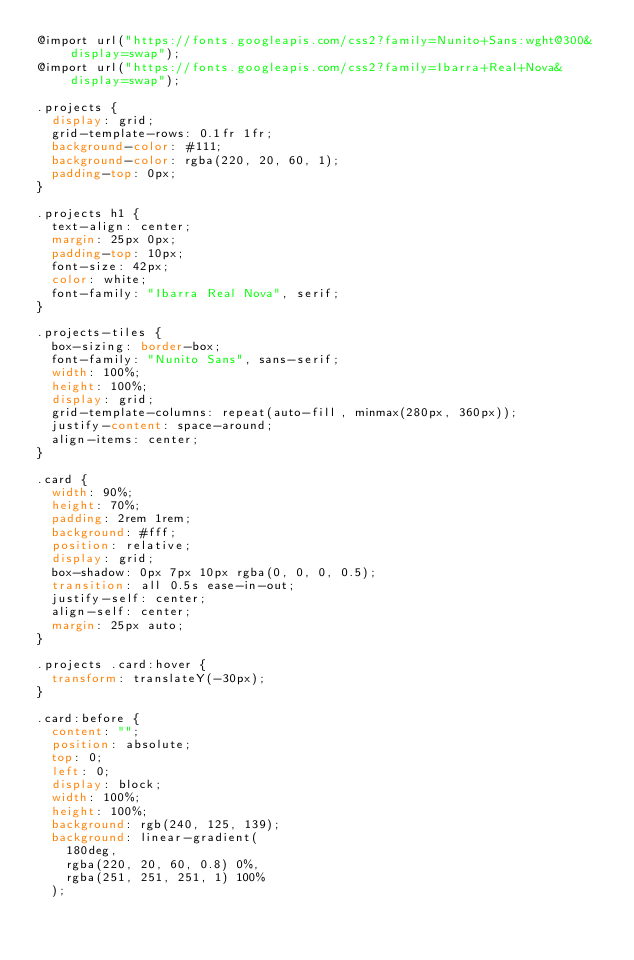<code> <loc_0><loc_0><loc_500><loc_500><_CSS_>@import url("https://fonts.googleapis.com/css2?family=Nunito+Sans:wght@300&display=swap");
@import url("https://fonts.googleapis.com/css2?family=Ibarra+Real+Nova&display=swap");

.projects {
  display: grid;
  grid-template-rows: 0.1fr 1fr;
  background-color: #111;
  background-color: rgba(220, 20, 60, 1);
  padding-top: 0px;
}

.projects h1 {
  text-align: center;
  margin: 25px 0px;
  padding-top: 10px;
  font-size: 42px;
  color: white;
  font-family: "Ibarra Real Nova", serif;
}

.projects-tiles {
  box-sizing: border-box;
  font-family: "Nunito Sans", sans-serif;
  width: 100%;
  height: 100%;
  display: grid;
  grid-template-columns: repeat(auto-fill, minmax(280px, 360px));
  justify-content: space-around;
  align-items: center;
}

.card {
  width: 90%;
  height: 70%;
  padding: 2rem 1rem;
  background: #fff;
  position: relative;
  display: grid;
  box-shadow: 0px 7px 10px rgba(0, 0, 0, 0.5);
  transition: all 0.5s ease-in-out;
  justify-self: center;
  align-self: center;
  margin: 25px auto;
}

.projects .card:hover {
  transform: translateY(-30px);
}

.card:before {
  content: "";
  position: absolute;
  top: 0;
  left: 0;
  display: block;
  width: 100%;
  height: 100%;
  background: rgb(240, 125, 139);
  background: linear-gradient(
    180deg,
    rgba(220, 20, 60, 0.8) 0%,
    rgba(251, 251, 251, 1) 100%
  );</code> 